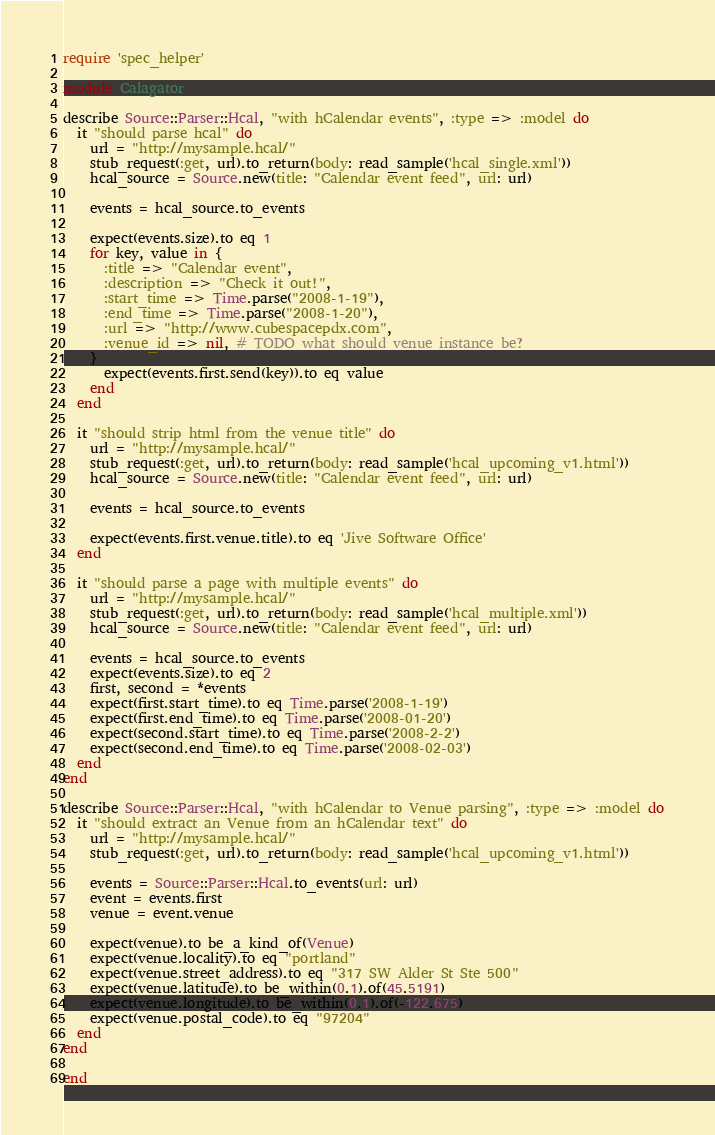<code> <loc_0><loc_0><loc_500><loc_500><_Ruby_>require 'spec_helper'

module Calagator

describe Source::Parser::Hcal, "with hCalendar events", :type => :model do
  it "should parse hcal" do
    url = "http://mysample.hcal/"
    stub_request(:get, url).to_return(body: read_sample('hcal_single.xml'))
    hcal_source = Source.new(title: "Calendar event feed", url: url)

    events = hcal_source.to_events

    expect(events.size).to eq 1
    for key, value in {
      :title => "Calendar event",
      :description => "Check it out!",
      :start_time => Time.parse("2008-1-19"),
      :end_time => Time.parse("2008-1-20"),
      :url => "http://www.cubespacepdx.com",
      :venue_id => nil, # TODO what should venue instance be?
    }
      expect(events.first.send(key)).to eq value
    end
  end

  it "should strip html from the venue title" do
    url = "http://mysample.hcal/"
    stub_request(:get, url).to_return(body: read_sample('hcal_upcoming_v1.html'))
    hcal_source = Source.new(title: "Calendar event feed", url: url)

    events = hcal_source.to_events

    expect(events.first.venue.title).to eq 'Jive Software Office'
  end

  it "should parse a page with multiple events" do
    url = "http://mysample.hcal/"
    stub_request(:get, url).to_return(body: read_sample('hcal_multiple.xml'))
    hcal_source = Source.new(title: "Calendar event feed", url: url)

    events = hcal_source.to_events
    expect(events.size).to eq 2
    first, second = *events
    expect(first.start_time).to eq Time.parse('2008-1-19')
    expect(first.end_time).to eq Time.parse('2008-01-20')
    expect(second.start_time).to eq Time.parse('2008-2-2')
    expect(second.end_time).to eq Time.parse('2008-02-03')
  end
end

describe Source::Parser::Hcal, "with hCalendar to Venue parsing", :type => :model do
  it "should extract an Venue from an hCalendar text" do
    url = "http://mysample.hcal/"
    stub_request(:get, url).to_return(body: read_sample('hcal_upcoming_v1.html'))

    events = Source::Parser::Hcal.to_events(url: url)
    event = events.first
    venue = event.venue

    expect(venue).to be_a_kind_of(Venue)
    expect(venue.locality).to eq "portland"
    expect(venue.street_address).to eq "317 SW Alder St Ste 500"
    expect(venue.latitude).to be_within(0.1).of(45.5191)
    expect(venue.longitude).to be_within(0.1).of(-122.675)
    expect(venue.postal_code).to eq "97204"
  end
end

end
</code> 